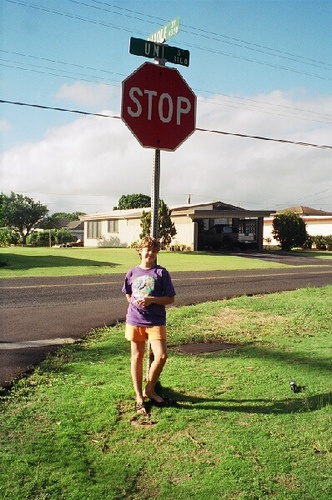Describe the objects in this image and their specific colors. I can see people in lightblue, black, maroon, tan, and ivory tones, stop sign in lightblue, maroon, gray, and lightgray tones, and truck in lightblue, black, and gray tones in this image. 